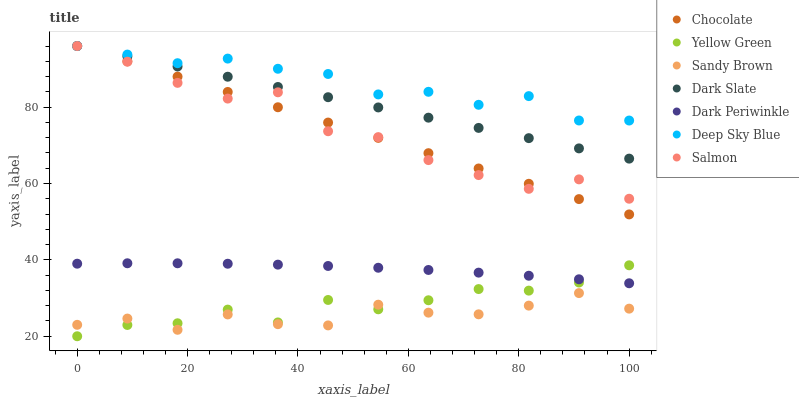Does Sandy Brown have the minimum area under the curve?
Answer yes or no. Yes. Does Deep Sky Blue have the maximum area under the curve?
Answer yes or no. Yes. Does Salmon have the minimum area under the curve?
Answer yes or no. No. Does Salmon have the maximum area under the curve?
Answer yes or no. No. Is Dark Slate the smoothest?
Answer yes or no. Yes. Is Salmon the roughest?
Answer yes or no. Yes. Is Chocolate the smoothest?
Answer yes or no. No. Is Chocolate the roughest?
Answer yes or no. No. Does Yellow Green have the lowest value?
Answer yes or no. Yes. Does Salmon have the lowest value?
Answer yes or no. No. Does Deep Sky Blue have the highest value?
Answer yes or no. Yes. Does Sandy Brown have the highest value?
Answer yes or no. No. Is Sandy Brown less than Dark Slate?
Answer yes or no. Yes. Is Dark Slate greater than Dark Periwinkle?
Answer yes or no. Yes. Does Chocolate intersect Salmon?
Answer yes or no. Yes. Is Chocolate less than Salmon?
Answer yes or no. No. Is Chocolate greater than Salmon?
Answer yes or no. No. Does Sandy Brown intersect Dark Slate?
Answer yes or no. No. 